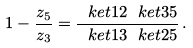Convert formula to latex. <formula><loc_0><loc_0><loc_500><loc_500>1 - \frac { z _ { 5 } } { z _ { 3 } } = \frac { \ k e t { 1 } { 2 } \ k e t { 3 } { 5 } } { \ k e t { 1 } { 3 } \ k e t { 2 } { 5 } } \, .</formula> 